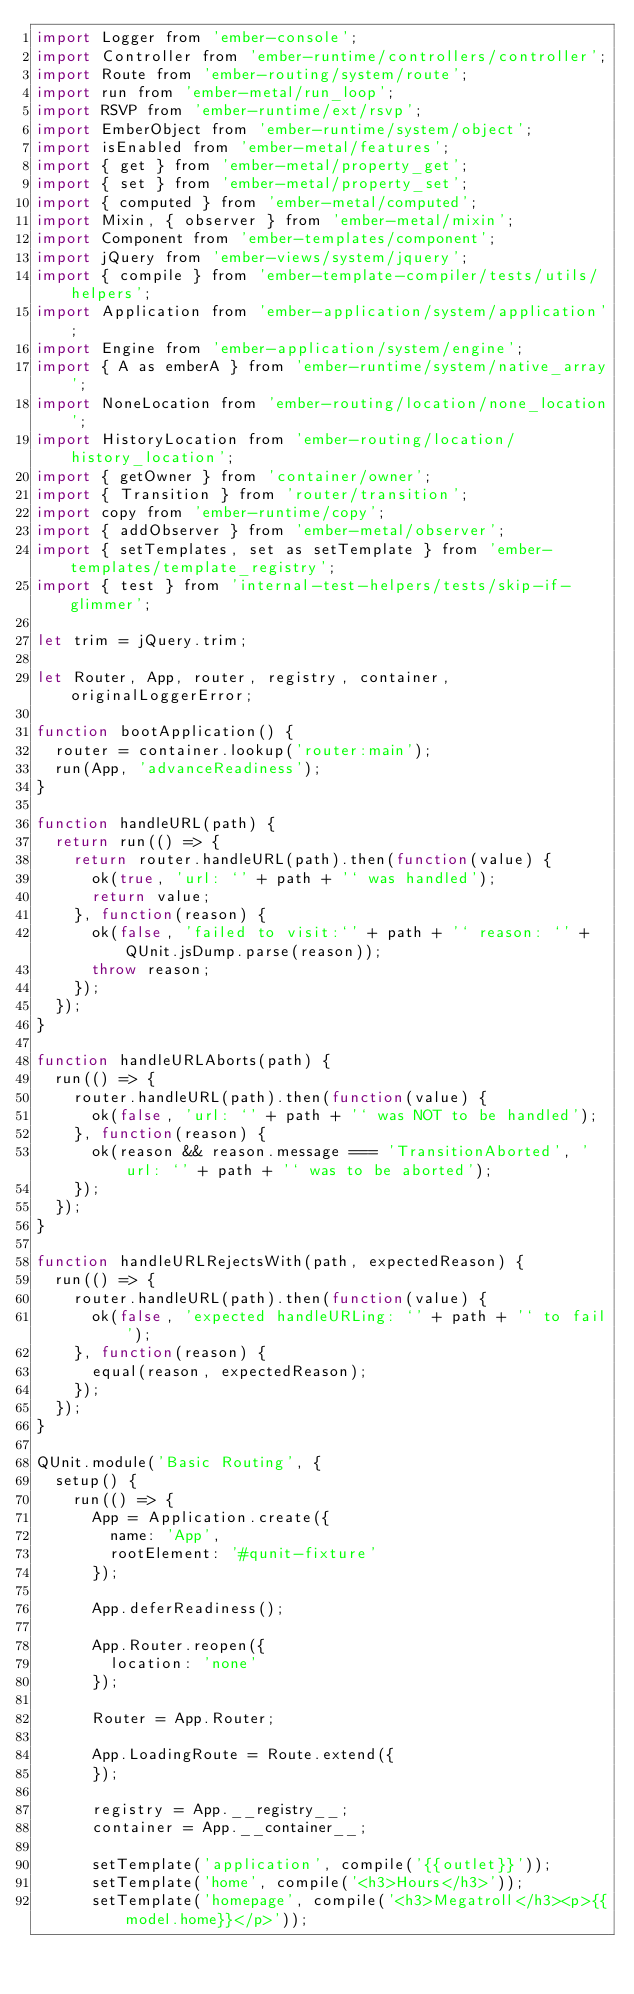<code> <loc_0><loc_0><loc_500><loc_500><_JavaScript_>import Logger from 'ember-console';
import Controller from 'ember-runtime/controllers/controller';
import Route from 'ember-routing/system/route';
import run from 'ember-metal/run_loop';
import RSVP from 'ember-runtime/ext/rsvp';
import EmberObject from 'ember-runtime/system/object';
import isEnabled from 'ember-metal/features';
import { get } from 'ember-metal/property_get';
import { set } from 'ember-metal/property_set';
import { computed } from 'ember-metal/computed';
import Mixin, { observer } from 'ember-metal/mixin';
import Component from 'ember-templates/component';
import jQuery from 'ember-views/system/jquery';
import { compile } from 'ember-template-compiler/tests/utils/helpers';
import Application from 'ember-application/system/application';
import Engine from 'ember-application/system/engine';
import { A as emberA } from 'ember-runtime/system/native_array';
import NoneLocation from 'ember-routing/location/none_location';
import HistoryLocation from 'ember-routing/location/history_location';
import { getOwner } from 'container/owner';
import { Transition } from 'router/transition';
import copy from 'ember-runtime/copy';
import { addObserver } from 'ember-metal/observer';
import { setTemplates, set as setTemplate } from 'ember-templates/template_registry';
import { test } from 'internal-test-helpers/tests/skip-if-glimmer';

let trim = jQuery.trim;

let Router, App, router, registry, container, originalLoggerError;

function bootApplication() {
  router = container.lookup('router:main');
  run(App, 'advanceReadiness');
}

function handleURL(path) {
  return run(() => {
    return router.handleURL(path).then(function(value) {
      ok(true, 'url: `' + path + '` was handled');
      return value;
    }, function(reason) {
      ok(false, 'failed to visit:`' + path + '` reason: `' + QUnit.jsDump.parse(reason));
      throw reason;
    });
  });
}

function handleURLAborts(path) {
  run(() => {
    router.handleURL(path).then(function(value) {
      ok(false, 'url: `' + path + '` was NOT to be handled');
    }, function(reason) {
      ok(reason && reason.message === 'TransitionAborted', 'url: `' + path + '` was to be aborted');
    });
  });
}

function handleURLRejectsWith(path, expectedReason) {
  run(() => {
    router.handleURL(path).then(function(value) {
      ok(false, 'expected handleURLing: `' + path + '` to fail');
    }, function(reason) {
      equal(reason, expectedReason);
    });
  });
}

QUnit.module('Basic Routing', {
  setup() {
    run(() => {
      App = Application.create({
        name: 'App',
        rootElement: '#qunit-fixture'
      });

      App.deferReadiness();

      App.Router.reopen({
        location: 'none'
      });

      Router = App.Router;

      App.LoadingRoute = Route.extend({
      });

      registry = App.__registry__;
      container = App.__container__;

      setTemplate('application', compile('{{outlet}}'));
      setTemplate('home', compile('<h3>Hours</h3>'));
      setTemplate('homepage', compile('<h3>Megatroll</h3><p>{{model.home}}</p>'));</code> 